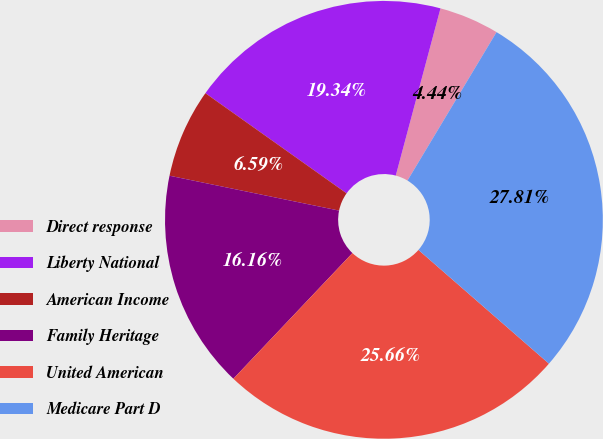<chart> <loc_0><loc_0><loc_500><loc_500><pie_chart><fcel>Direct response<fcel>Liberty National<fcel>American Income<fcel>Family Heritage<fcel>United American<fcel>Medicare Part D<nl><fcel>4.44%<fcel>19.34%<fcel>6.59%<fcel>16.16%<fcel>25.66%<fcel>27.81%<nl></chart> 